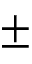<formula> <loc_0><loc_0><loc_500><loc_500>\pm</formula> 